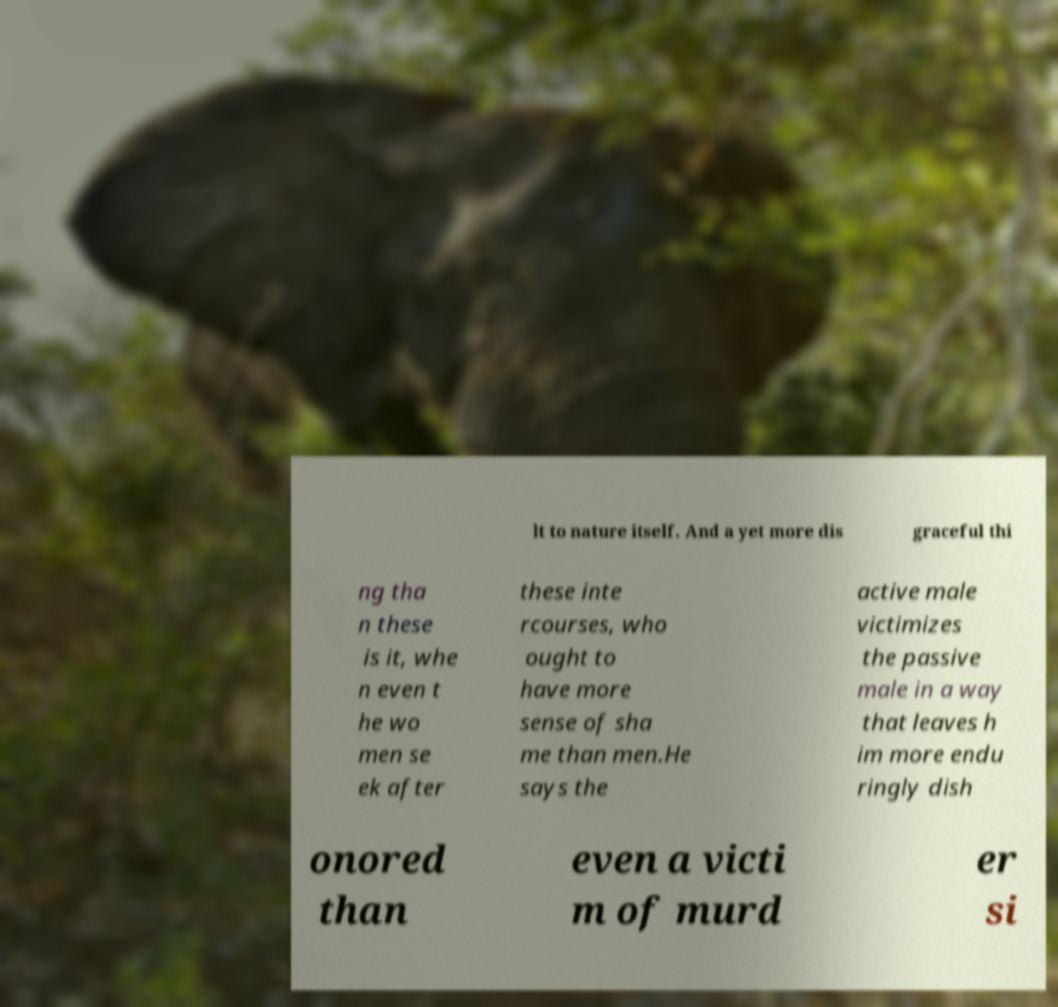What messages or text are displayed in this image? I need them in a readable, typed format. lt to nature itself. And a yet more dis graceful thi ng tha n these is it, whe n even t he wo men se ek after these inte rcourses, who ought to have more sense of sha me than men.He says the active male victimizes the passive male in a way that leaves h im more endu ringly dish onored than even a victi m of murd er si 